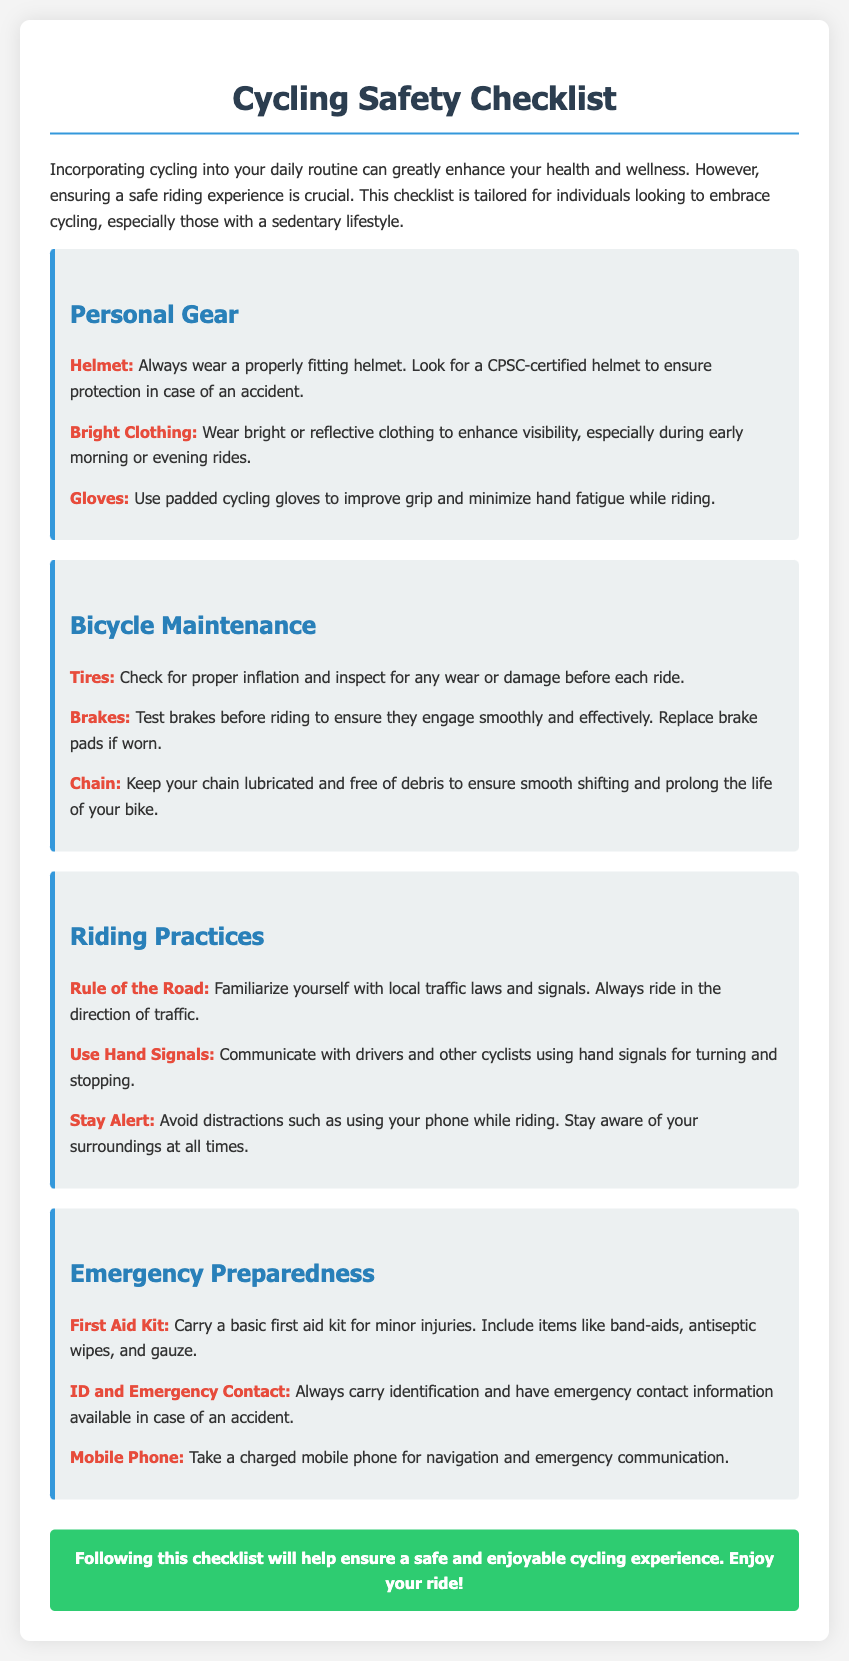What should you always wear while cycling? The manual emphasizes the importance of wearing a properly fitting helmet for safety while cycling.
Answer: Helmet What clothing is recommended for visibility during rides? Bright or reflective clothing is suggested to enhance visibility, especially during low-light conditions.
Answer: Bright Clothing What should you check for regarding bicycle tires? The checklist mentions checking for proper inflation and inspecting for any wear or damage before each ride.
Answer: Proper inflation and inspection What is a key practice for riding in traffic? Familiarizing yourself with local traffic laws and signals is critical as per the riding practices in the document.
Answer: Rule of the Road What items are included in the basic first aid kit? The checklist specifies band-aids, antiseptic wipes, and gauze as essential items for a first aid kit.
Answer: Band-aids, antiseptic wipes, gauze Why is it important to stay aware while cycling? Staying aware of surroundings is stressed to avoid distractions, which is essential for safe cycling.
Answer: Avoid distractions What should you carry for communication in emergencies? The document advises taking a charged mobile phone for emergency communication and navigation.
Answer: Mobile Phone How can cyclists signal their intentions? The use of hand signals for turning and stopping is recommended for communication with others.
Answer: Use Hand Signals What color clothing is preferred for cycling? Bright or reflective colors are preferred to ensure visibility on the road.
Answer: Bright Clothing 